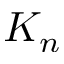<formula> <loc_0><loc_0><loc_500><loc_500>K _ { n }</formula> 